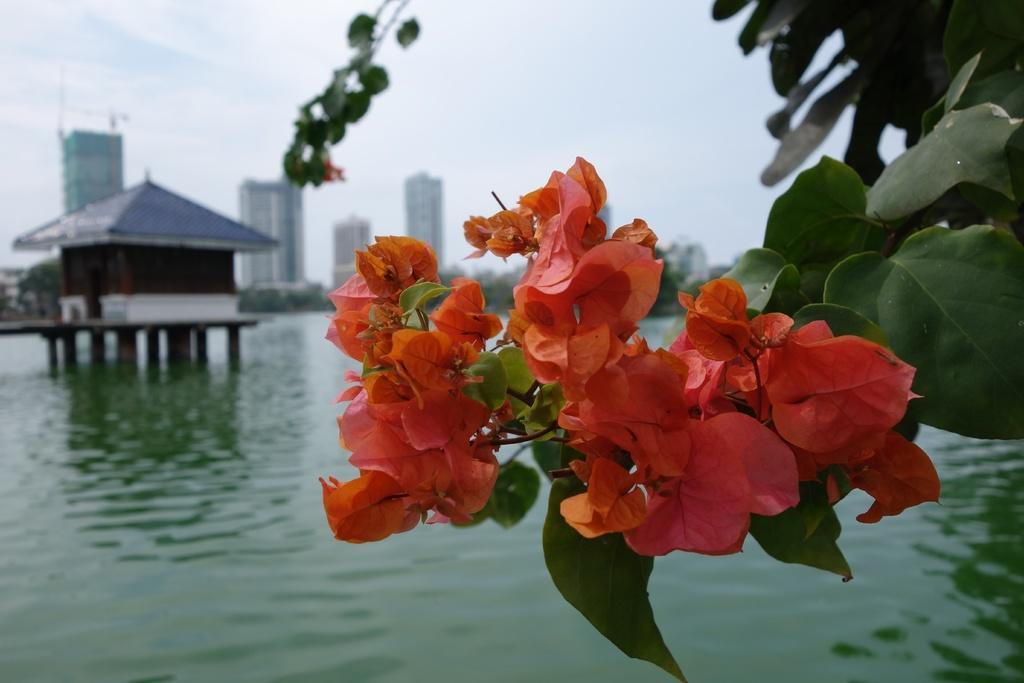Could you give a brief overview of what you see in this image? In this picture we can see flowers, leaves, water, house, buildings, trees and in the background we can see the sky. 